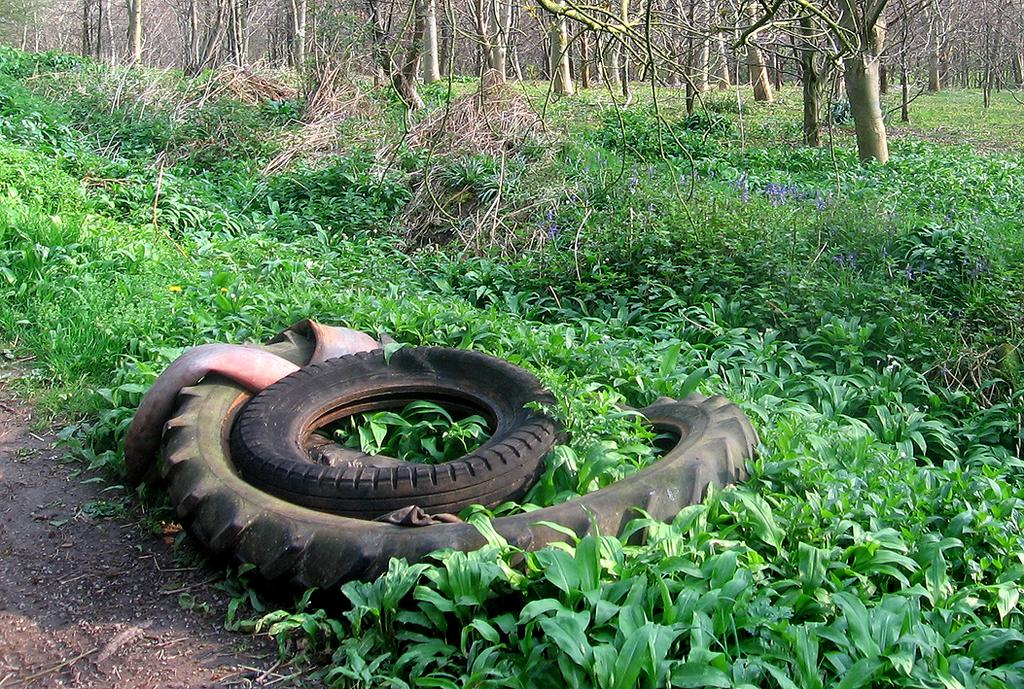What can be seen in the background of the image? There are branches visible in the background of the image. What type of vegetation is present in the image? There are plants in the image. What is located at the bottom portion of the image? Wires and the ground are present at the bottom portion of the image. What type of punishment is being administered to the plants in the image? There is no punishment being administered to the plants in the image; they are simply present. What kind of lunch is being served on the branches in the image? There is no lunch being served in the image; it only features branches and plants. 